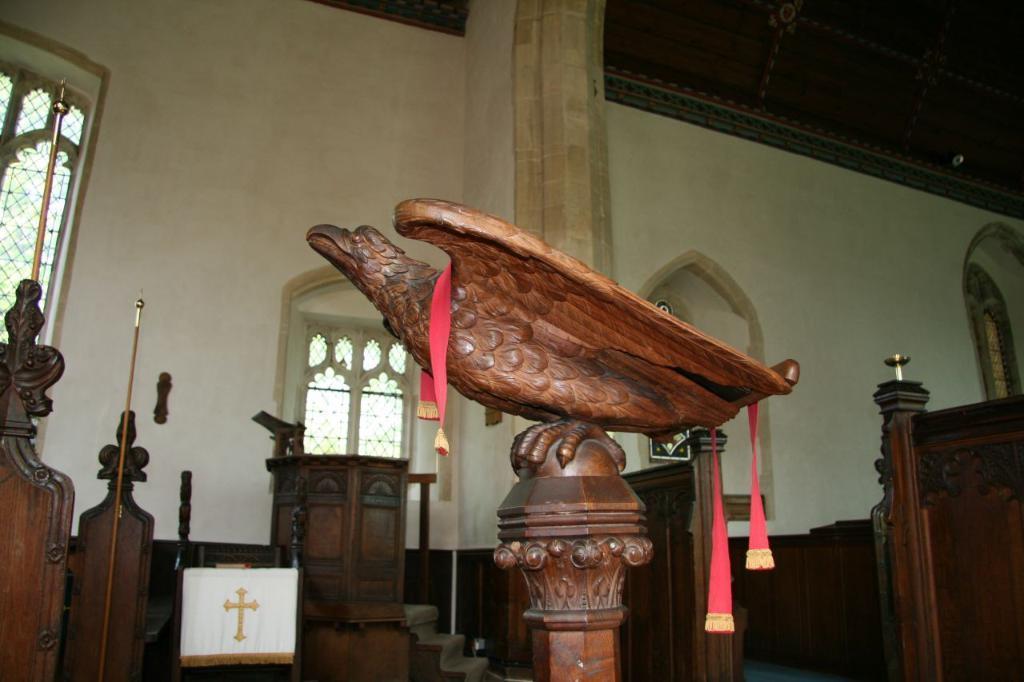Please provide a concise description of this image. In this image I can see a statue of a bird which is in brown color, background I can see a podium, a window and the wall is in cream color. 